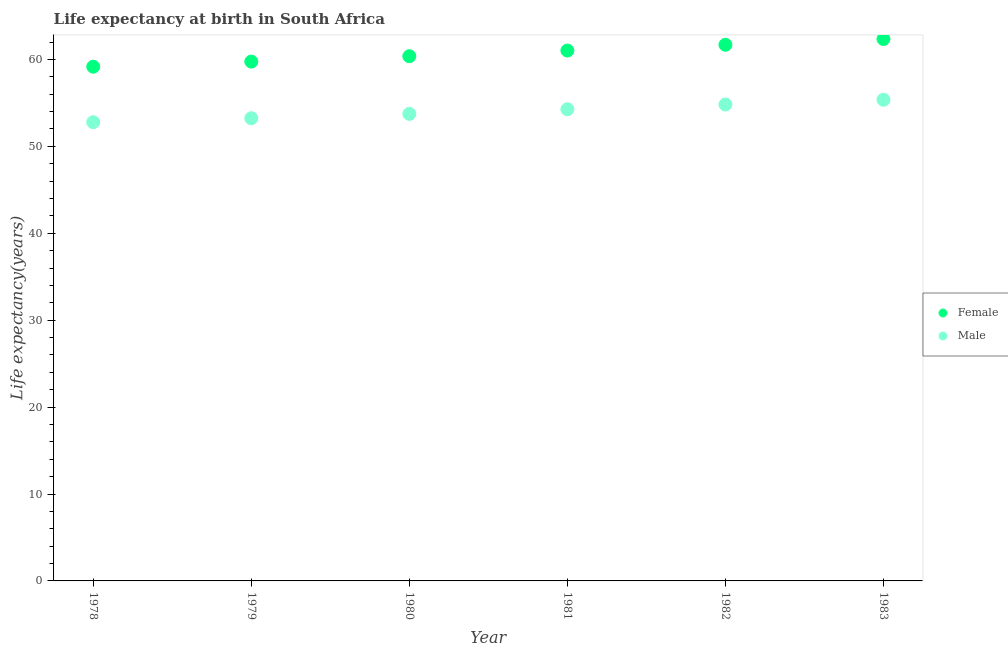Is the number of dotlines equal to the number of legend labels?
Offer a very short reply. Yes. What is the life expectancy(female) in 1979?
Your answer should be compact. 59.75. Across all years, what is the maximum life expectancy(female)?
Your response must be concise. 62.35. Across all years, what is the minimum life expectancy(female)?
Offer a terse response. 59.16. In which year was the life expectancy(female) maximum?
Give a very brief answer. 1983. In which year was the life expectancy(female) minimum?
Provide a succinct answer. 1978. What is the total life expectancy(male) in the graph?
Ensure brevity in your answer.  324.19. What is the difference between the life expectancy(male) in 1982 and that in 1983?
Keep it short and to the point. -0.55. What is the difference between the life expectancy(female) in 1979 and the life expectancy(male) in 1980?
Provide a short and direct response. 6.02. What is the average life expectancy(female) per year?
Your response must be concise. 60.72. In the year 1982, what is the difference between the life expectancy(male) and life expectancy(female)?
Your response must be concise. -6.87. In how many years, is the life expectancy(male) greater than 20 years?
Your answer should be compact. 6. What is the ratio of the life expectancy(male) in 1979 to that in 1982?
Provide a short and direct response. 0.97. Is the life expectancy(female) in 1978 less than that in 1981?
Provide a succinct answer. Yes. Is the difference between the life expectancy(female) in 1981 and 1983 greater than the difference between the life expectancy(male) in 1981 and 1983?
Provide a short and direct response. No. What is the difference between the highest and the second highest life expectancy(female)?
Keep it short and to the point. 0.66. What is the difference between the highest and the lowest life expectancy(male)?
Your answer should be compact. 2.58. In how many years, is the life expectancy(female) greater than the average life expectancy(female) taken over all years?
Offer a very short reply. 3. Does the life expectancy(male) monotonically increase over the years?
Ensure brevity in your answer.  Yes. Is the life expectancy(female) strictly less than the life expectancy(male) over the years?
Your answer should be very brief. No. How many dotlines are there?
Make the answer very short. 2. Are the values on the major ticks of Y-axis written in scientific E-notation?
Offer a very short reply. No. Does the graph contain any zero values?
Your answer should be very brief. No. Does the graph contain grids?
Your response must be concise. No. How many legend labels are there?
Your answer should be compact. 2. What is the title of the graph?
Ensure brevity in your answer.  Life expectancy at birth in South Africa. What is the label or title of the Y-axis?
Keep it short and to the point. Life expectancy(years). What is the Life expectancy(years) in Female in 1978?
Offer a terse response. 59.16. What is the Life expectancy(years) of Male in 1978?
Your answer should be very brief. 52.78. What is the Life expectancy(years) of Female in 1979?
Keep it short and to the point. 59.75. What is the Life expectancy(years) of Male in 1979?
Your answer should be very brief. 53.24. What is the Life expectancy(years) of Female in 1980?
Offer a very short reply. 60.37. What is the Life expectancy(years) of Male in 1980?
Make the answer very short. 53.74. What is the Life expectancy(years) of Female in 1981?
Ensure brevity in your answer.  61.02. What is the Life expectancy(years) of Male in 1981?
Your answer should be compact. 54.27. What is the Life expectancy(years) of Female in 1982?
Your answer should be compact. 61.69. What is the Life expectancy(years) of Male in 1982?
Keep it short and to the point. 54.81. What is the Life expectancy(years) of Female in 1983?
Keep it short and to the point. 62.35. What is the Life expectancy(years) of Male in 1983?
Your response must be concise. 55.36. Across all years, what is the maximum Life expectancy(years) in Female?
Give a very brief answer. 62.35. Across all years, what is the maximum Life expectancy(years) of Male?
Provide a succinct answer. 55.36. Across all years, what is the minimum Life expectancy(years) in Female?
Your answer should be very brief. 59.16. Across all years, what is the minimum Life expectancy(years) in Male?
Give a very brief answer. 52.78. What is the total Life expectancy(years) of Female in the graph?
Offer a very short reply. 364.34. What is the total Life expectancy(years) of Male in the graph?
Provide a short and direct response. 324.19. What is the difference between the Life expectancy(years) of Female in 1978 and that in 1979?
Offer a terse response. -0.59. What is the difference between the Life expectancy(years) of Male in 1978 and that in 1979?
Your answer should be very brief. -0.46. What is the difference between the Life expectancy(years) of Female in 1978 and that in 1980?
Give a very brief answer. -1.21. What is the difference between the Life expectancy(years) in Male in 1978 and that in 1980?
Give a very brief answer. -0.96. What is the difference between the Life expectancy(years) in Female in 1978 and that in 1981?
Make the answer very short. -1.86. What is the difference between the Life expectancy(years) of Male in 1978 and that in 1981?
Keep it short and to the point. -1.49. What is the difference between the Life expectancy(years) in Female in 1978 and that in 1982?
Make the answer very short. -2.52. What is the difference between the Life expectancy(years) of Male in 1978 and that in 1982?
Offer a terse response. -2.04. What is the difference between the Life expectancy(years) of Female in 1978 and that in 1983?
Your answer should be very brief. -3.18. What is the difference between the Life expectancy(years) of Male in 1978 and that in 1983?
Your response must be concise. -2.58. What is the difference between the Life expectancy(years) of Female in 1979 and that in 1980?
Ensure brevity in your answer.  -0.62. What is the difference between the Life expectancy(years) in Male in 1979 and that in 1980?
Offer a terse response. -0.5. What is the difference between the Life expectancy(years) of Female in 1979 and that in 1981?
Your answer should be compact. -1.27. What is the difference between the Life expectancy(years) in Male in 1979 and that in 1981?
Give a very brief answer. -1.03. What is the difference between the Life expectancy(years) of Female in 1979 and that in 1982?
Give a very brief answer. -1.94. What is the difference between the Life expectancy(years) of Male in 1979 and that in 1982?
Give a very brief answer. -1.58. What is the difference between the Life expectancy(years) in Female in 1979 and that in 1983?
Your response must be concise. -2.6. What is the difference between the Life expectancy(years) in Male in 1979 and that in 1983?
Keep it short and to the point. -2.12. What is the difference between the Life expectancy(years) in Female in 1980 and that in 1981?
Offer a terse response. -0.65. What is the difference between the Life expectancy(years) of Male in 1980 and that in 1981?
Your answer should be compact. -0.53. What is the difference between the Life expectancy(years) of Female in 1980 and that in 1982?
Make the answer very short. -1.31. What is the difference between the Life expectancy(years) in Male in 1980 and that in 1982?
Make the answer very short. -1.08. What is the difference between the Life expectancy(years) of Female in 1980 and that in 1983?
Provide a succinct answer. -1.98. What is the difference between the Life expectancy(years) in Male in 1980 and that in 1983?
Give a very brief answer. -1.62. What is the difference between the Life expectancy(years) in Female in 1981 and that in 1982?
Offer a very short reply. -0.67. What is the difference between the Life expectancy(years) in Male in 1981 and that in 1982?
Your response must be concise. -0.55. What is the difference between the Life expectancy(years) of Female in 1981 and that in 1983?
Offer a terse response. -1.33. What is the difference between the Life expectancy(years) of Male in 1981 and that in 1983?
Provide a succinct answer. -1.09. What is the difference between the Life expectancy(years) of Female in 1982 and that in 1983?
Your answer should be compact. -0.66. What is the difference between the Life expectancy(years) of Male in 1982 and that in 1983?
Give a very brief answer. -0.55. What is the difference between the Life expectancy(years) of Female in 1978 and the Life expectancy(years) of Male in 1979?
Ensure brevity in your answer.  5.93. What is the difference between the Life expectancy(years) in Female in 1978 and the Life expectancy(years) in Male in 1980?
Give a very brief answer. 5.43. What is the difference between the Life expectancy(years) of Female in 1978 and the Life expectancy(years) of Male in 1981?
Make the answer very short. 4.9. What is the difference between the Life expectancy(years) of Female in 1978 and the Life expectancy(years) of Male in 1982?
Provide a succinct answer. 4.35. What is the difference between the Life expectancy(years) in Female in 1978 and the Life expectancy(years) in Male in 1983?
Offer a terse response. 3.8. What is the difference between the Life expectancy(years) in Female in 1979 and the Life expectancy(years) in Male in 1980?
Ensure brevity in your answer.  6.01. What is the difference between the Life expectancy(years) of Female in 1979 and the Life expectancy(years) of Male in 1981?
Provide a short and direct response. 5.48. What is the difference between the Life expectancy(years) of Female in 1979 and the Life expectancy(years) of Male in 1982?
Keep it short and to the point. 4.94. What is the difference between the Life expectancy(years) in Female in 1979 and the Life expectancy(years) in Male in 1983?
Make the answer very short. 4.39. What is the difference between the Life expectancy(years) in Female in 1980 and the Life expectancy(years) in Male in 1981?
Keep it short and to the point. 6.1. What is the difference between the Life expectancy(years) in Female in 1980 and the Life expectancy(years) in Male in 1982?
Keep it short and to the point. 5.56. What is the difference between the Life expectancy(years) of Female in 1980 and the Life expectancy(years) of Male in 1983?
Offer a terse response. 5.01. What is the difference between the Life expectancy(years) of Female in 1981 and the Life expectancy(years) of Male in 1982?
Offer a very short reply. 6.21. What is the difference between the Life expectancy(years) in Female in 1981 and the Life expectancy(years) in Male in 1983?
Make the answer very short. 5.66. What is the difference between the Life expectancy(years) of Female in 1982 and the Life expectancy(years) of Male in 1983?
Ensure brevity in your answer.  6.33. What is the average Life expectancy(years) in Female per year?
Offer a terse response. 60.72. What is the average Life expectancy(years) in Male per year?
Your response must be concise. 54.03. In the year 1978, what is the difference between the Life expectancy(years) of Female and Life expectancy(years) of Male?
Keep it short and to the point. 6.39. In the year 1979, what is the difference between the Life expectancy(years) of Female and Life expectancy(years) of Male?
Ensure brevity in your answer.  6.51. In the year 1980, what is the difference between the Life expectancy(years) of Female and Life expectancy(years) of Male?
Ensure brevity in your answer.  6.64. In the year 1981, what is the difference between the Life expectancy(years) of Female and Life expectancy(years) of Male?
Offer a terse response. 6.75. In the year 1982, what is the difference between the Life expectancy(years) in Female and Life expectancy(years) in Male?
Provide a succinct answer. 6.87. In the year 1983, what is the difference between the Life expectancy(years) in Female and Life expectancy(years) in Male?
Provide a succinct answer. 6.99. What is the ratio of the Life expectancy(years) of Female in 1978 to that in 1979?
Offer a very short reply. 0.99. What is the ratio of the Life expectancy(years) in Male in 1978 to that in 1980?
Your answer should be very brief. 0.98. What is the ratio of the Life expectancy(years) of Female in 1978 to that in 1981?
Offer a very short reply. 0.97. What is the ratio of the Life expectancy(years) of Male in 1978 to that in 1981?
Offer a terse response. 0.97. What is the ratio of the Life expectancy(years) of Female in 1978 to that in 1982?
Ensure brevity in your answer.  0.96. What is the ratio of the Life expectancy(years) in Male in 1978 to that in 1982?
Ensure brevity in your answer.  0.96. What is the ratio of the Life expectancy(years) of Female in 1978 to that in 1983?
Offer a very short reply. 0.95. What is the ratio of the Life expectancy(years) of Male in 1978 to that in 1983?
Ensure brevity in your answer.  0.95. What is the ratio of the Life expectancy(years) of Female in 1979 to that in 1981?
Your response must be concise. 0.98. What is the ratio of the Life expectancy(years) of Male in 1979 to that in 1981?
Provide a succinct answer. 0.98. What is the ratio of the Life expectancy(years) in Female in 1979 to that in 1982?
Your answer should be very brief. 0.97. What is the ratio of the Life expectancy(years) in Male in 1979 to that in 1982?
Offer a very short reply. 0.97. What is the ratio of the Life expectancy(years) of Male in 1979 to that in 1983?
Your answer should be very brief. 0.96. What is the ratio of the Life expectancy(years) in Female in 1980 to that in 1981?
Keep it short and to the point. 0.99. What is the ratio of the Life expectancy(years) in Male in 1980 to that in 1981?
Offer a very short reply. 0.99. What is the ratio of the Life expectancy(years) of Female in 1980 to that in 1982?
Provide a succinct answer. 0.98. What is the ratio of the Life expectancy(years) in Male in 1980 to that in 1982?
Your answer should be compact. 0.98. What is the ratio of the Life expectancy(years) of Female in 1980 to that in 1983?
Ensure brevity in your answer.  0.97. What is the ratio of the Life expectancy(years) of Male in 1980 to that in 1983?
Ensure brevity in your answer.  0.97. What is the ratio of the Life expectancy(years) of Female in 1981 to that in 1983?
Provide a succinct answer. 0.98. What is the ratio of the Life expectancy(years) in Male in 1981 to that in 1983?
Give a very brief answer. 0.98. What is the ratio of the Life expectancy(years) of Male in 1982 to that in 1983?
Keep it short and to the point. 0.99. What is the difference between the highest and the second highest Life expectancy(years) of Female?
Offer a very short reply. 0.66. What is the difference between the highest and the second highest Life expectancy(years) in Male?
Provide a short and direct response. 0.55. What is the difference between the highest and the lowest Life expectancy(years) of Female?
Offer a terse response. 3.18. What is the difference between the highest and the lowest Life expectancy(years) of Male?
Offer a terse response. 2.58. 